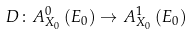Convert formula to latex. <formula><loc_0><loc_0><loc_500><loc_500>D \colon A _ { X _ { 0 } } ^ { 0 } \left ( E _ { 0 } \right ) \rightarrow A _ { X _ { 0 } } ^ { 1 } \left ( E _ { 0 } \right )</formula> 